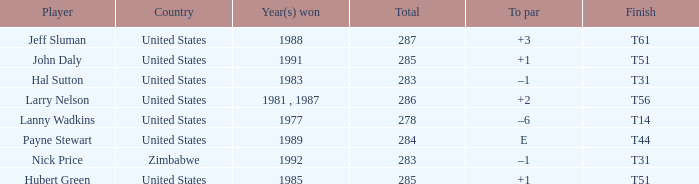What is Country, when Total is greater than 283, and when Year(s) Won is "1989"? United States. 